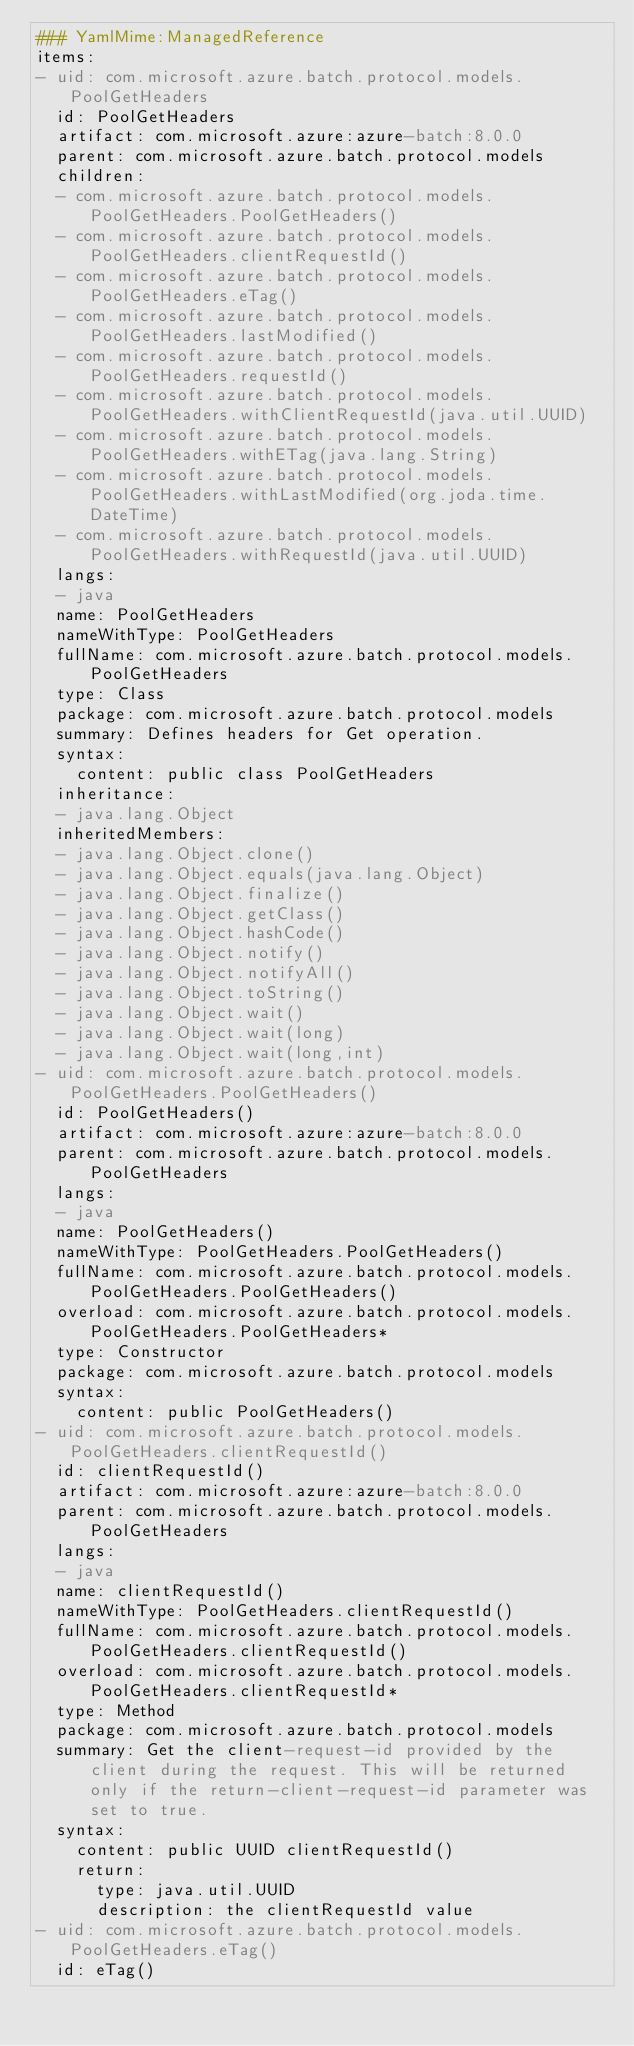<code> <loc_0><loc_0><loc_500><loc_500><_YAML_>### YamlMime:ManagedReference
items:
- uid: com.microsoft.azure.batch.protocol.models.PoolGetHeaders
  id: PoolGetHeaders
  artifact: com.microsoft.azure:azure-batch:8.0.0
  parent: com.microsoft.azure.batch.protocol.models
  children:
  - com.microsoft.azure.batch.protocol.models.PoolGetHeaders.PoolGetHeaders()
  - com.microsoft.azure.batch.protocol.models.PoolGetHeaders.clientRequestId()
  - com.microsoft.azure.batch.protocol.models.PoolGetHeaders.eTag()
  - com.microsoft.azure.batch.protocol.models.PoolGetHeaders.lastModified()
  - com.microsoft.azure.batch.protocol.models.PoolGetHeaders.requestId()
  - com.microsoft.azure.batch.protocol.models.PoolGetHeaders.withClientRequestId(java.util.UUID)
  - com.microsoft.azure.batch.protocol.models.PoolGetHeaders.withETag(java.lang.String)
  - com.microsoft.azure.batch.protocol.models.PoolGetHeaders.withLastModified(org.joda.time.DateTime)
  - com.microsoft.azure.batch.protocol.models.PoolGetHeaders.withRequestId(java.util.UUID)
  langs:
  - java
  name: PoolGetHeaders
  nameWithType: PoolGetHeaders
  fullName: com.microsoft.azure.batch.protocol.models.PoolGetHeaders
  type: Class
  package: com.microsoft.azure.batch.protocol.models
  summary: Defines headers for Get operation.
  syntax:
    content: public class PoolGetHeaders
  inheritance:
  - java.lang.Object
  inheritedMembers:
  - java.lang.Object.clone()
  - java.lang.Object.equals(java.lang.Object)
  - java.lang.Object.finalize()
  - java.lang.Object.getClass()
  - java.lang.Object.hashCode()
  - java.lang.Object.notify()
  - java.lang.Object.notifyAll()
  - java.lang.Object.toString()
  - java.lang.Object.wait()
  - java.lang.Object.wait(long)
  - java.lang.Object.wait(long,int)
- uid: com.microsoft.azure.batch.protocol.models.PoolGetHeaders.PoolGetHeaders()
  id: PoolGetHeaders()
  artifact: com.microsoft.azure:azure-batch:8.0.0
  parent: com.microsoft.azure.batch.protocol.models.PoolGetHeaders
  langs:
  - java
  name: PoolGetHeaders()
  nameWithType: PoolGetHeaders.PoolGetHeaders()
  fullName: com.microsoft.azure.batch.protocol.models.PoolGetHeaders.PoolGetHeaders()
  overload: com.microsoft.azure.batch.protocol.models.PoolGetHeaders.PoolGetHeaders*
  type: Constructor
  package: com.microsoft.azure.batch.protocol.models
  syntax:
    content: public PoolGetHeaders()
- uid: com.microsoft.azure.batch.protocol.models.PoolGetHeaders.clientRequestId()
  id: clientRequestId()
  artifact: com.microsoft.azure:azure-batch:8.0.0
  parent: com.microsoft.azure.batch.protocol.models.PoolGetHeaders
  langs:
  - java
  name: clientRequestId()
  nameWithType: PoolGetHeaders.clientRequestId()
  fullName: com.microsoft.azure.batch.protocol.models.PoolGetHeaders.clientRequestId()
  overload: com.microsoft.azure.batch.protocol.models.PoolGetHeaders.clientRequestId*
  type: Method
  package: com.microsoft.azure.batch.protocol.models
  summary: Get the client-request-id provided by the client during the request. This will be returned only if the return-client-request-id parameter was set to true.
  syntax:
    content: public UUID clientRequestId()
    return:
      type: java.util.UUID
      description: the clientRequestId value
- uid: com.microsoft.azure.batch.protocol.models.PoolGetHeaders.eTag()
  id: eTag()</code> 